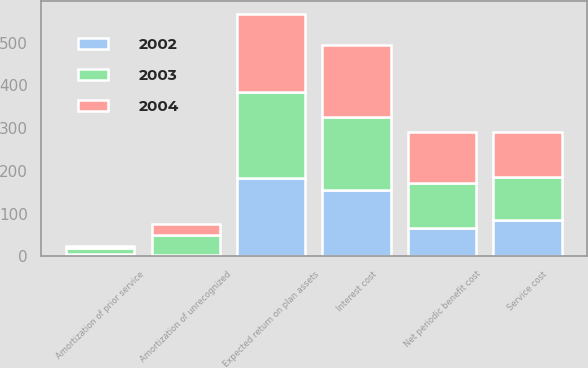Convert chart. <chart><loc_0><loc_0><loc_500><loc_500><stacked_bar_chart><ecel><fcel>Service cost<fcel>Interest cost<fcel>Expected return on plan assets<fcel>Amortization of prior service<fcel>Amortization of unrecognized<fcel>Net periodic benefit cost<nl><fcel>2003<fcel>101<fcel>171<fcel>201<fcel>13<fcel>46<fcel>104<nl><fcel>2004<fcel>105<fcel>167<fcel>184<fcel>6<fcel>26<fcel>120<nl><fcel>2002<fcel>84<fcel>156<fcel>183<fcel>6<fcel>4<fcel>67<nl></chart> 